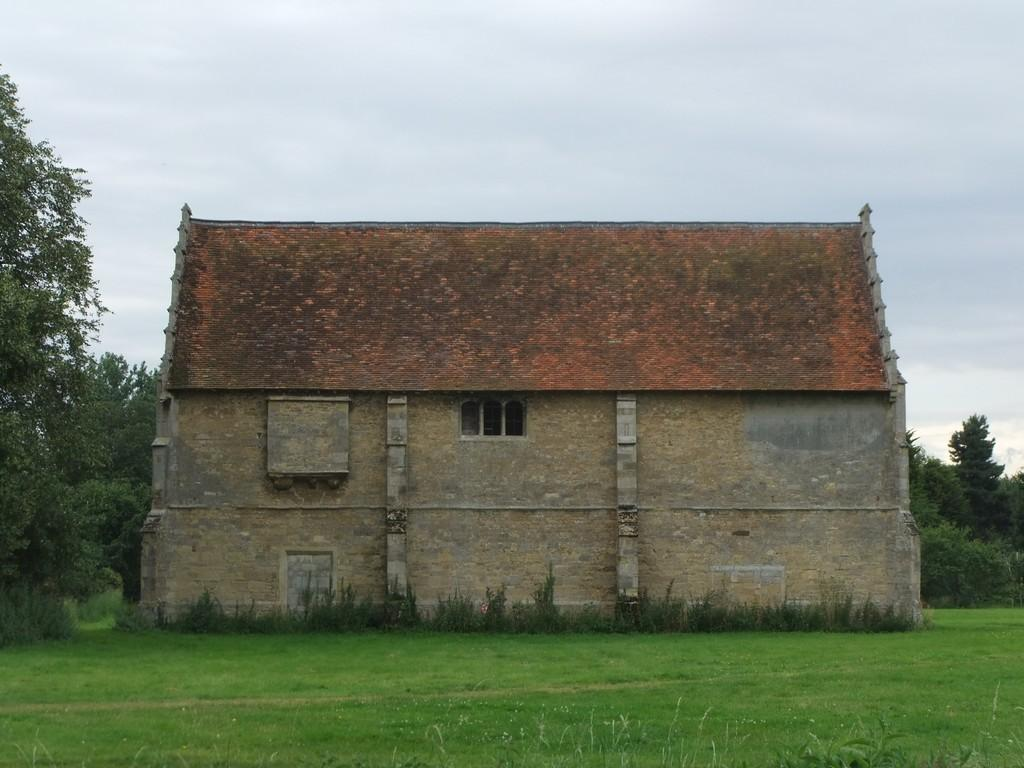What is the main structure in the center of the image? There is a house in the center of the image. What type of vegetation can be seen on the right side of the image? There are trees on the right side of the image. What type of vegetation can be seen on the left side of the image? There are trees on the left side of the image. What is visible at the bottom of the image? There is grass at the bottom of the image. What is visible at the top of the image? The sky is visible at the top of the image. How many letters are visible on the country in the image? There is no country or letters present in the image; it features a house surrounded by trees and grass. What causes the burst of colors in the image? There is no burst of colors in the image; the colors are consistent and natural, featuring a house, trees, grass, and sky. 